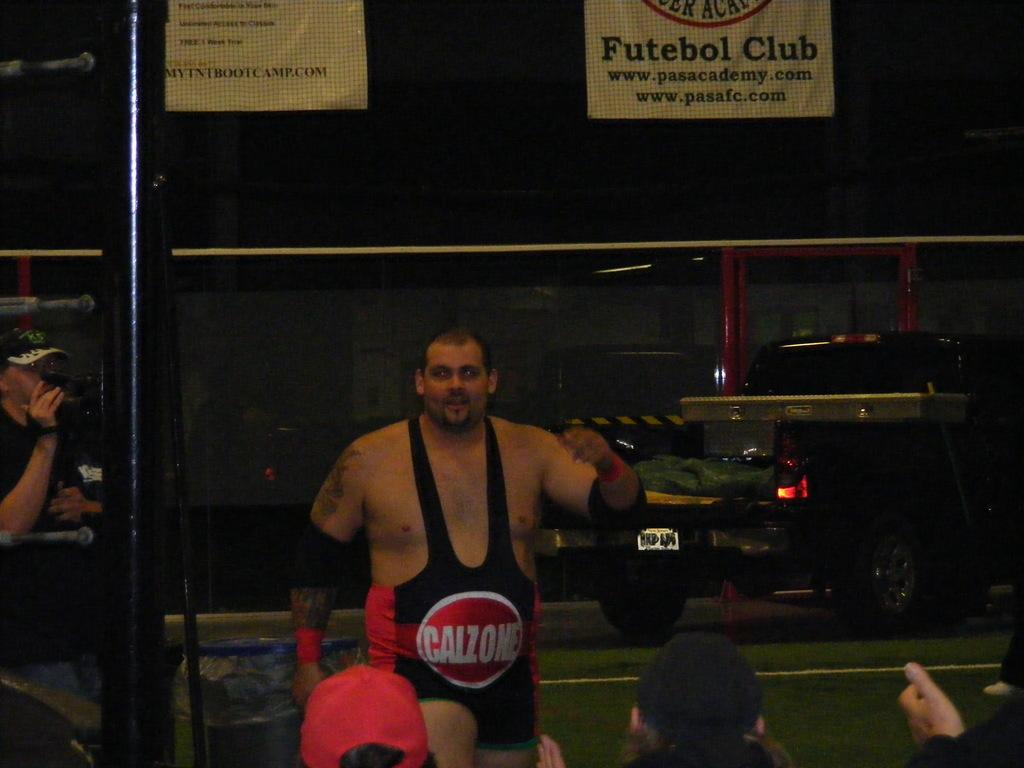<image>
Provide a brief description of the given image. A man is wearing a wrestling uniform with a large red circle saying Calzone on the belly. 